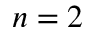<formula> <loc_0><loc_0><loc_500><loc_500>n = 2</formula> 